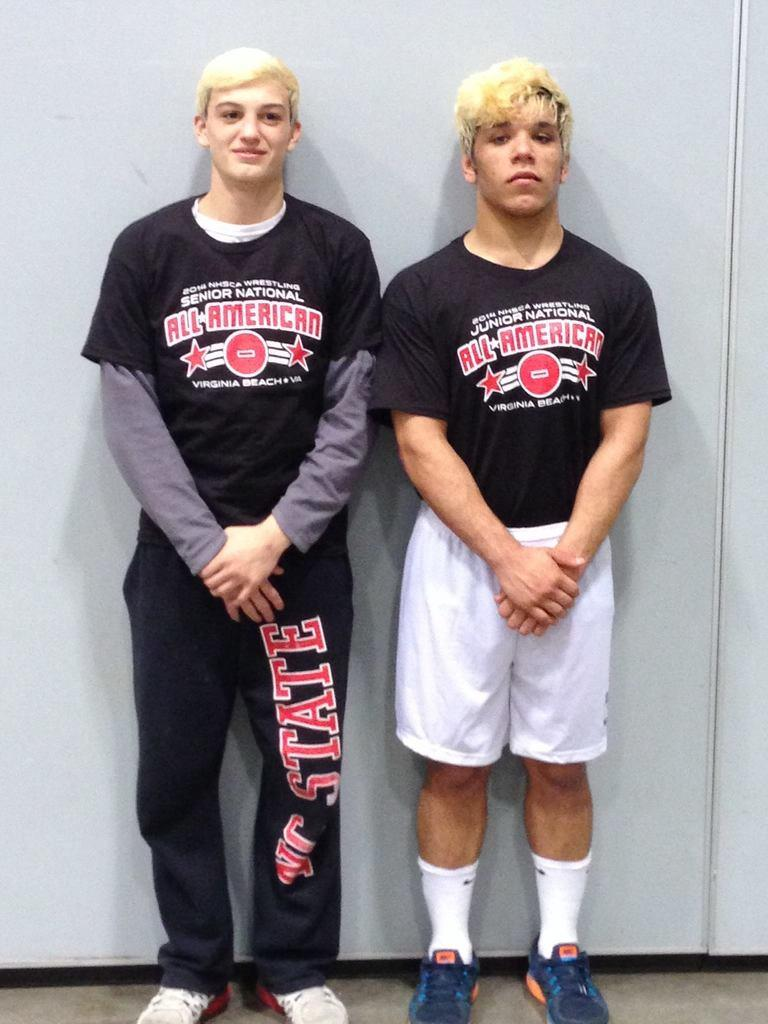<image>
Write a terse but informative summary of the picture. Two boys wearing shirts that say All American on it. 